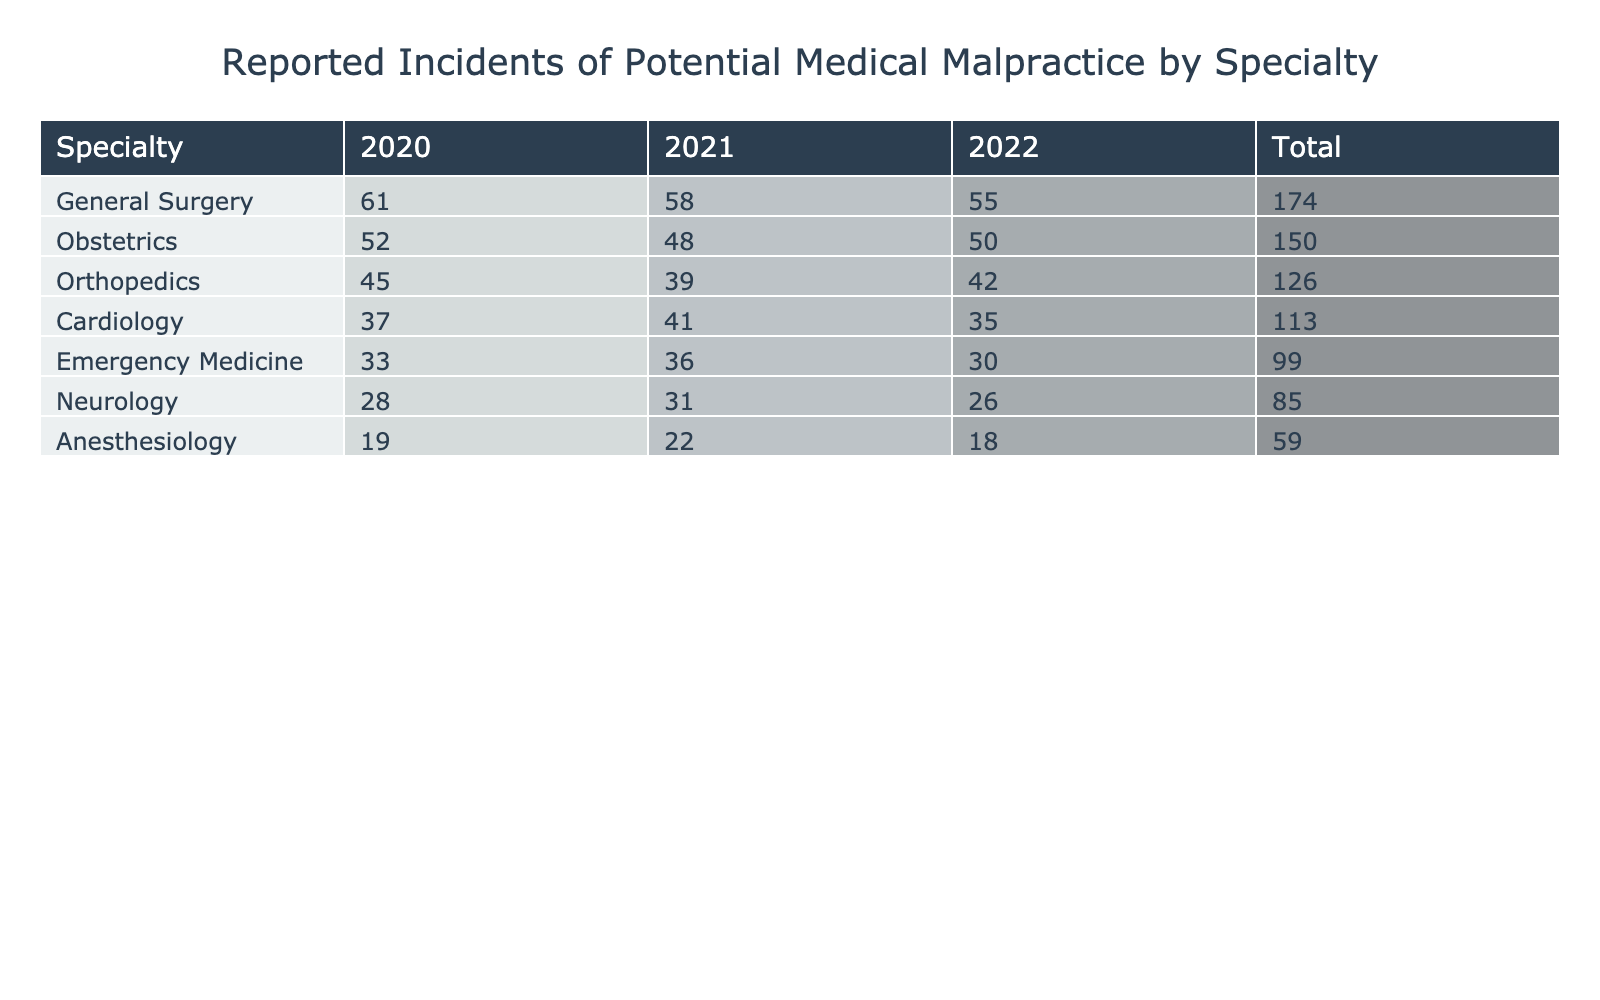What specialty reported the highest number of incidents in 2021? In 2021, the reported incidents can be found in the "Reported Incidents" column for each specialty. General Surgery has the highest number with 58 incidents.
Answer: General Surgery What was the total number of reported incidents for Obstetrics over the three years? To find the total for Obstetrics, add the reported incidents for 2020 (52), 2021 (48), and 2022 (50). The total is 52 + 48 + 50 = 150.
Answer: 150 In which year did Anesthesiology have the fewest reported incidents? By examining Anesthesiology's incidents across the years, we see 19 in 2020, 22 in 2021, and 18 in 2022. The fewest incidents was 18 in 2022.
Answer: 2022 What is the average number of reported incidents for Orthopedics over the three years? The incidents for Orthopedics are 45 in 2020, 39 in 2021, and 42 in 2022. The sum is 45 + 39 + 42 = 126. There are 3 years, so the average is 126 / 3 = 42.
Answer: 42 Did Neurology report more incidents in 2021 than in 2020? Neurology reported 28 incidents in 2020 and 31 in 2021. Since 31 is greater than 28, the answer is yes.
Answer: Yes Which specialty had a total of 132 incidents across all years? To find this, we calculate the total incidents for each specialty. For Anesthesiology, the total is 19 + 22 + 18 = 59 which is less than 132. After checking others, we find that no specialty matches a total of 132 incidents.
Answer: None What was the percentage increase in reported incidents for Cardiology from 2020 to 2021? For Cardiology, the incidents were 37 in 2020 and 41 in 2021. The increase is 41 - 37 = 4. The percentage increase is (4 / 37) * 100, which equals approximately 10.81%.
Answer: 10.81% Which specialty reported the least number of incidents in 2020? Checking the values for 2020, Anesthesiology had the least number of incidents with 19.
Answer: Anesthesiology What is the total number of incidents for Emergency Medicine over the three years? Emergency Medicine reported incidents of 33 in 2020, 36 in 2021, and 30 in 2022. Adding these gives 33 + 36 + 30 = 99.
Answer: 99 What is the difference in reported incidents between the highest and lowest specialty totals? The highest total is for General Surgery (174) and the lowest is for Anesthesiology (59). The difference is 174 - 59 = 115.
Answer: 115 